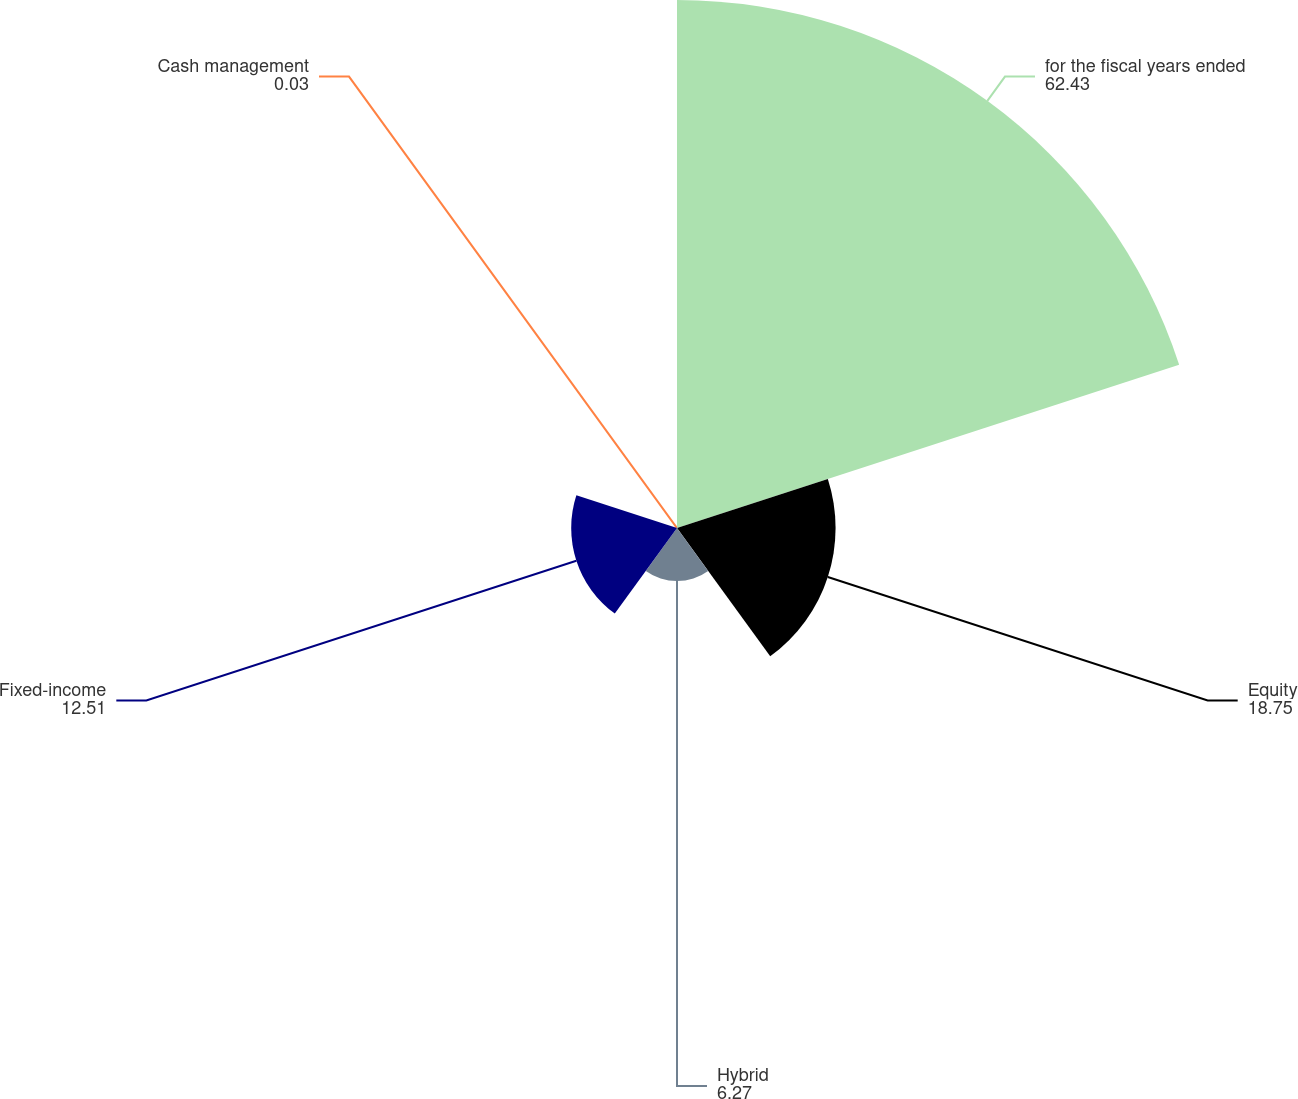Convert chart. <chart><loc_0><loc_0><loc_500><loc_500><pie_chart><fcel>for the fiscal years ended<fcel>Equity<fcel>Hybrid<fcel>Fixed-income<fcel>Cash management<nl><fcel>62.43%<fcel>18.75%<fcel>6.27%<fcel>12.51%<fcel>0.03%<nl></chart> 